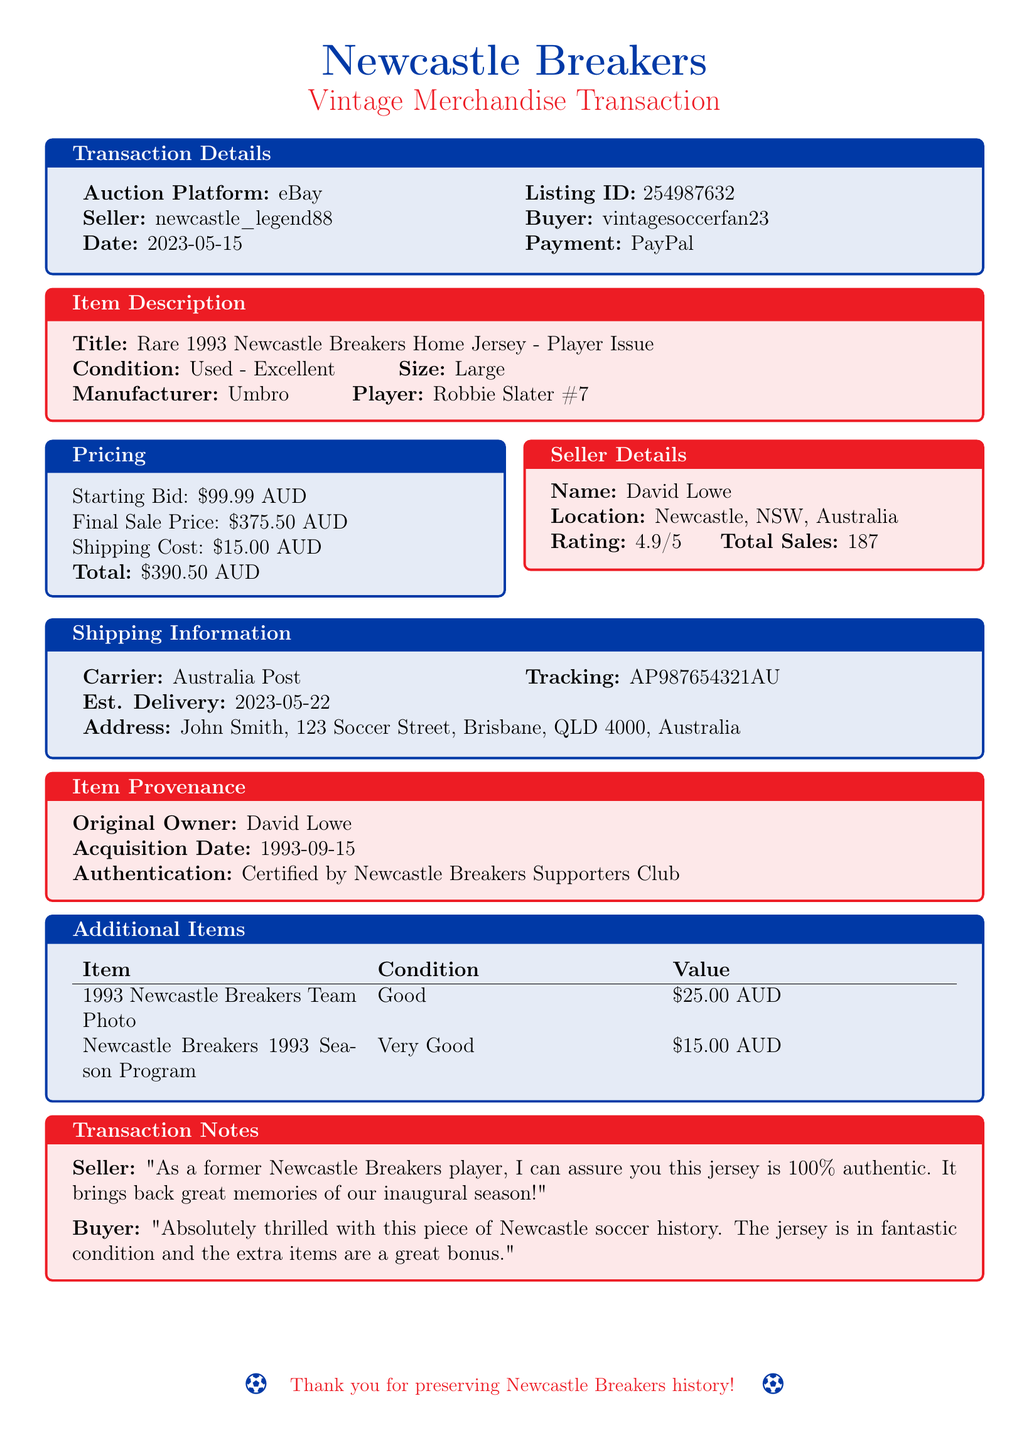What is the auction platform used for the sale? The auction platform used for this transaction is mentioned in the document as eBay.
Answer: eBay What is the final sale price of the jersey? The document states the final sale price for the jersey.
Answer: 375.50 Who is the original owner of the item? The original owner of the jersey is specified in the item provenance section of the document.
Answer: David Lowe What method of payment was used? The document indicates the payment method used for the transaction.
Answer: PayPal How much does shipping cost? The shipping cost is explicitly stated in the pricing section of the document.
Answer: 15.00 What is the buyer's username? The document provides the buyer's username as part of the transaction details.
Answer: vintagesoccerfan23 What is the seller's rating? The seller's rating is presented in the seller details section of the document.
Answer: 4.9 What is included as an additional item? One of the additional items listed in the document is the 1993 Newcastle Breakers Team Photo.
Answer: 1993 Newcastle Breakers Team Photo On what date was the jersey acquired? The acquisition date is noted in the item provenance section of the document.
Answer: 1993-09-15 